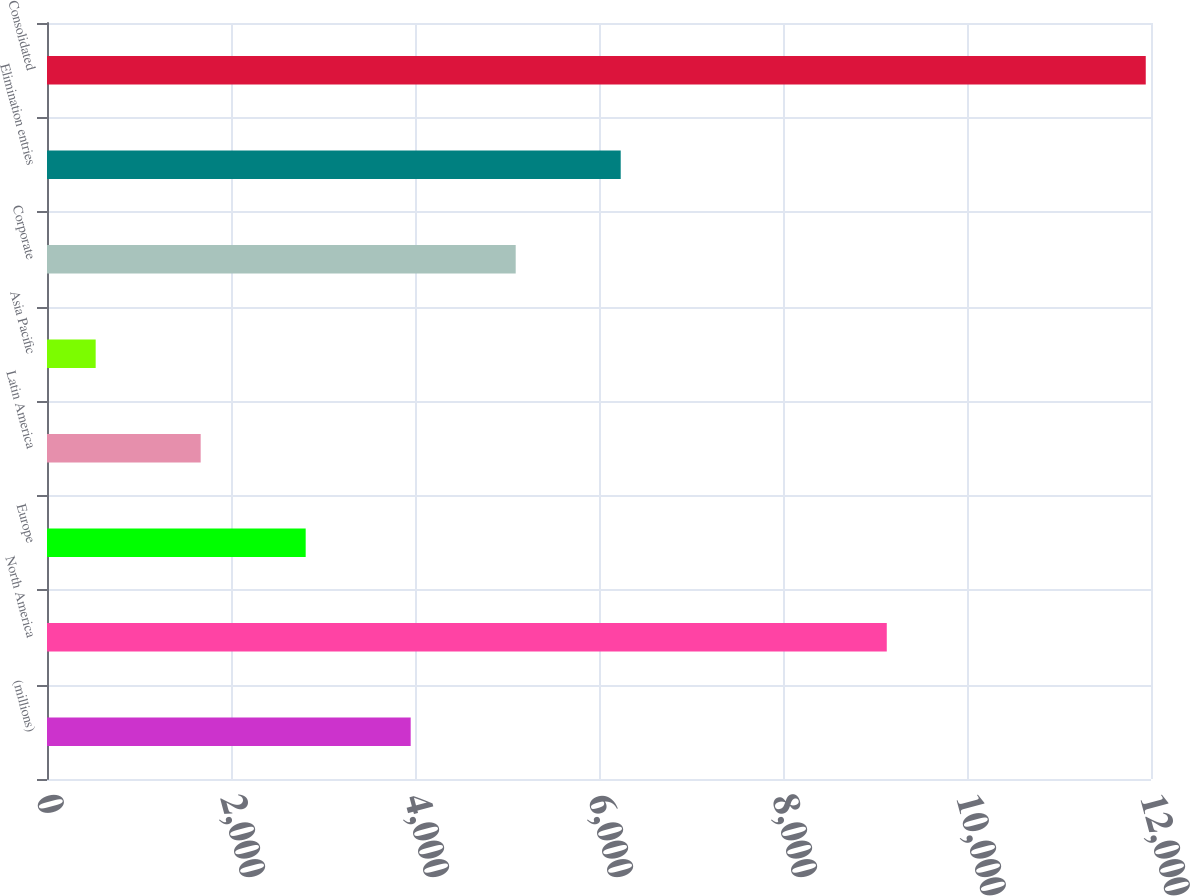Convert chart. <chart><loc_0><loc_0><loc_500><loc_500><bar_chart><fcel>(millions)<fcel>North America<fcel>Europe<fcel>Latin America<fcel>Asia Pacific<fcel>Corporate<fcel>Elimination entries<fcel>Consolidated<nl><fcel>3953.2<fcel>9128<fcel>2811.8<fcel>1670.4<fcel>529<fcel>5094.6<fcel>6236<fcel>11943<nl></chart> 